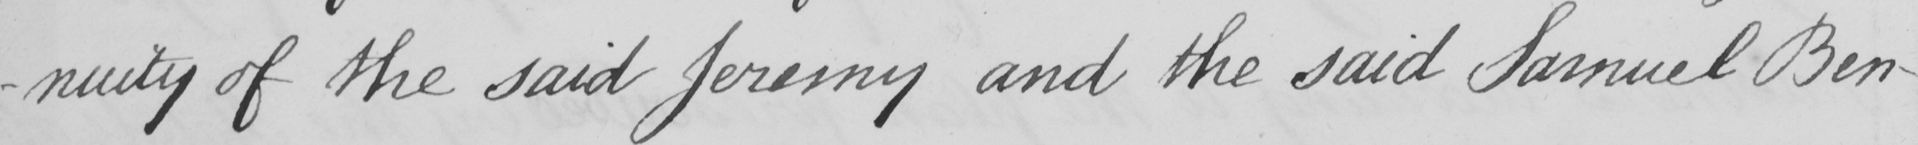Transcribe the text shown in this historical manuscript line. -nuity of the said Jeremy and the said Samuel Ben- 